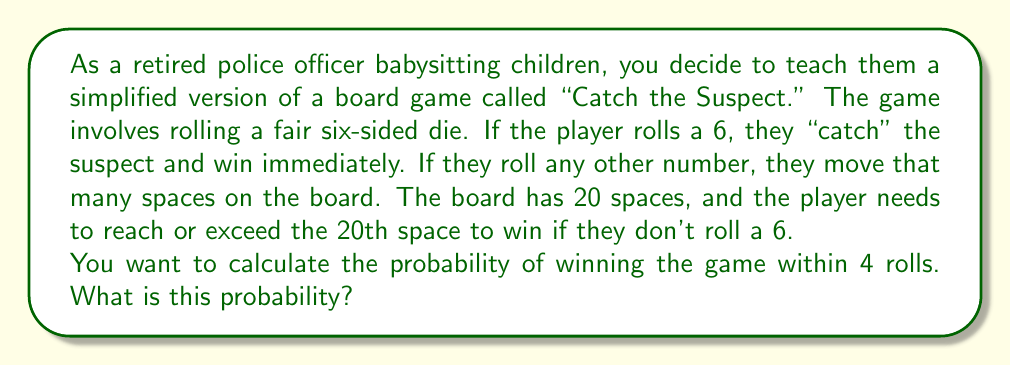Provide a solution to this math problem. Let's approach this step-by-step:

1) First, we need to consider the ways to win:
   a) Roll a 6 on any of the 4 rolls
   b) Reach or exceed 20 spaces within 4 rolls

2) Probability of winning by rolling a 6:
   - Probability of rolling a 6 on a single roll: $P(6) = \frac{1}{6}$
   - Probability of not rolling a 6 on a single roll: $P(\text{not } 6) = \frac{5}{6}$
   - Probability of rolling at least one 6 in 4 rolls:
     $$P(\text{at least one 6}) = 1 - P(\text{no 6 in 4 rolls}) = 1 - (\frac{5}{6})^4 = 0.5177$$

3) Probability of winning by reaching 20 spaces:
   - To reach 20 spaces in exactly 4 rolls, we need a sum of 20, 21, 22, 23, or 24
   - The probability of each sum can be calculated using the probability generating function:
     $$P(X) = (\frac{1}{6}x + \frac{1}{6}x^2 + \frac{1}{6}x^3 + \frac{1}{6}x^4 + \frac{1}{6}x^5)^4$$
   - Extracting the coefficients of $x^{20}$ to $x^{24}$ and summing them:
     $$P(20 \leq \text{sum} \leq 24) = 0.0320$$

4) The total probability of winning is the sum of these two probabilities:
   $$P(\text{win}) = 0.5177 + 0.0320 = 0.5497$$

Therefore, the probability of winning the game within 4 rolls is approximately 0.5497 or 54.97%.
Answer: The probability of winning the "Catch the Suspect" game within 4 rolls is approximately 0.5497 or 54.97%. 